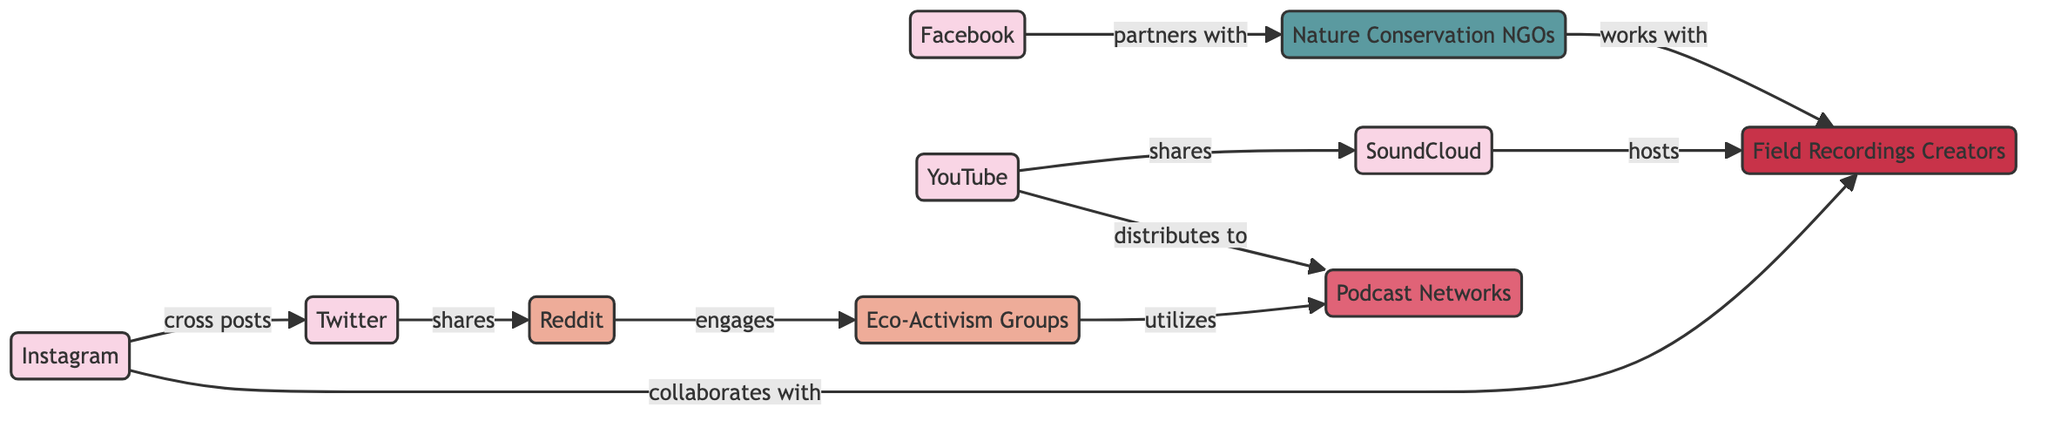What is the total number of nodes in the diagram? To find the total number of nodes, we can count each distinct node listed in the data section. There are 10 nodes: Twitter, Facebook, Instagram, Reddit, YouTube, Podcast Networks, Eco-Activism Groups, Field Recordings Creators, SoundCloud, and Nature Conservation NGOs.
Answer: 10 Which platform collaborates with Field Recordings Creators? By examining the connections in the diagram, we can identify that Instagram is the platform which has a direct collaboration with Field Recordings Creators, as represented by the "collaborates with" label.
Answer: Instagram How many types of nodes are represented in the diagram? The diagram has nodes of five different types: platform, community, distribution channel, content creator, and organization. By listing these types, we can confirm the diversity within the nodes.
Answer: 5 What is the relationship between YouTube and Podcast Networks? The edge between YouTube and Podcast Networks shows that YouTube "distributes to" Podcast Networks, indicating a directional relationship in terms of content distribution.
Answer: distributes to Which community engages with Eco-Activism Groups? The edge that connects Reddit and Eco-Activism Groups shows the "engages" relationship. This indicates that Reddit is actively engaging with Eco-Activism Groups as part of its activities.
Answer: Reddit What platform shares content with SoundCloud? Referring to the edges in the diagram, we see that YouTube shares content with SoundCloud, indicating a direct sharing relationship between these two platforms.
Answer: YouTube How many relationships involve the platform Facebook? By checking the edges, Facebook has one relationship: it partners with Nature Conservation NGOs. Therefore, the total number of relationships involving Facebook is one.
Answer: 1 Which types of nodes do Field Recordings Creators collaborate with? By looking at the edges involving Field Recordings Creators, we can see they are only linked to Instagram, meaning they collaborate exclusively with this platform.
Answer: platform What is the main distribution channel utilized by Eco-Activism Groups? The edge indicates that Eco-Activism Groups utilize Podcast Networks for distribution purposes. This means that Podcast Networks is the primary distribution channel for Eco-Activism Groups.
Answer: Podcast Networks 